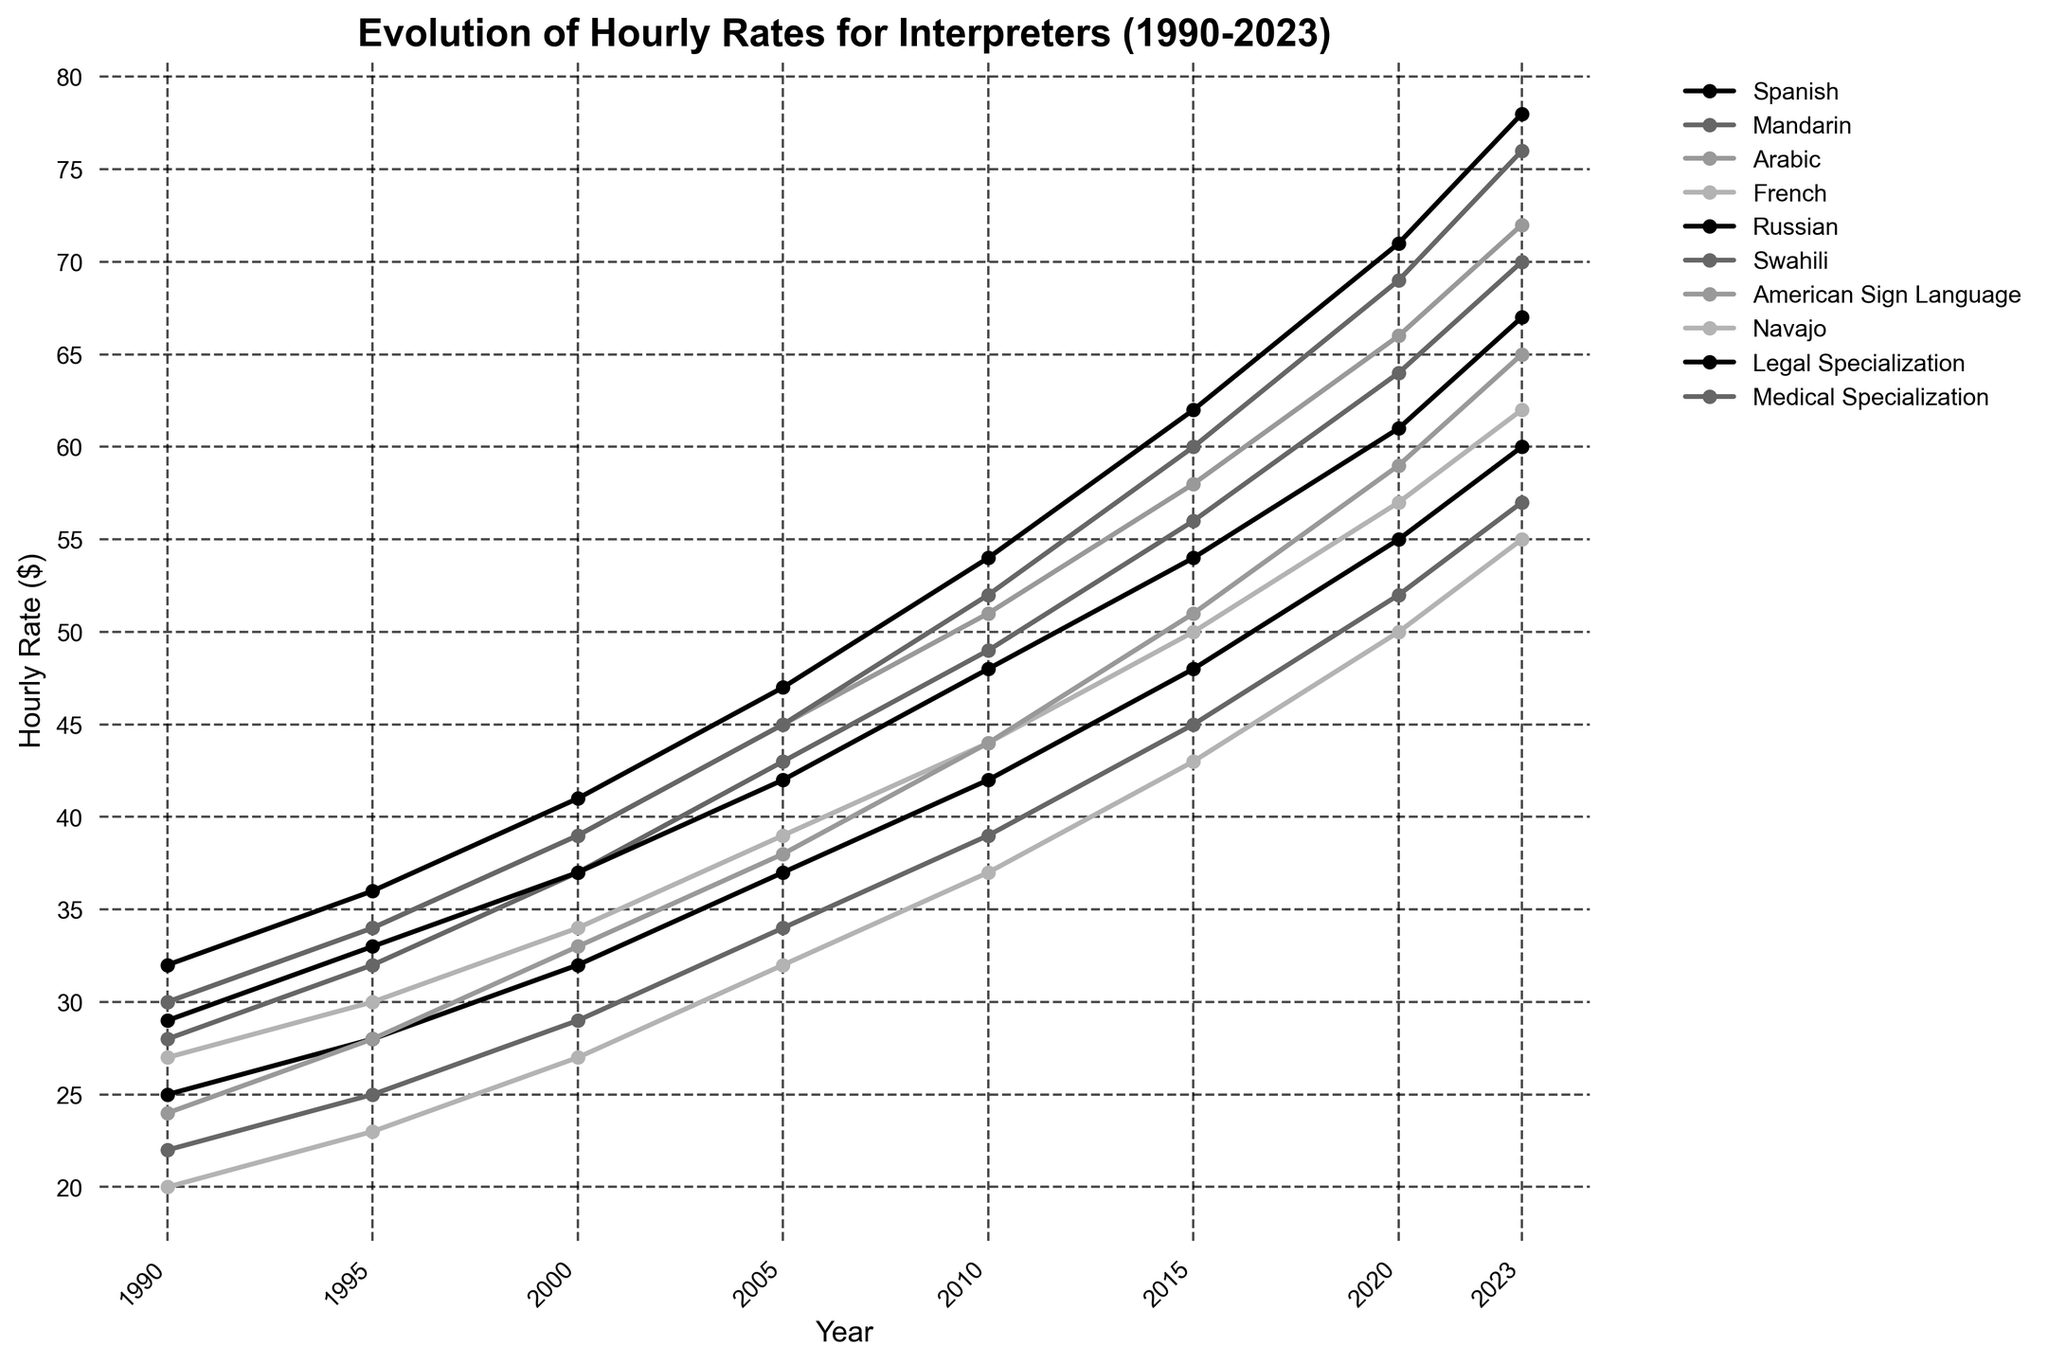Which language had the highest hourly rate in 2023? Look at the endpoints of each line in 2023 and identify the highest value. Arabic has the highest with $72 per hour.
Answer: Arabic What was the hourly rate for Navajo interpreters in 2000? Locate the value for Navajo interpreters in the column for the year 2000. The rate was $27.
Answer: $27 How much did the hourly rate for Spanish interpreters increase from 1990 to 2023? Subtract the 1990 value for Spanish interpreters from the 2023 value: $60 - $25 = $35.
Answer: $35 Which specialization saw the largest increase in hourly rates from 1990 to 2023? Calculate the differences for Legal Specialization ($78 - $32 = $46) and Medical Specialization ($76 - $30 = $46), both saw an increase of $46.
Answer: Both By how much did the hourly rate for Mandarin interpreters increase between 2015 and 2020? Subtract the 2015 value for Mandarin from the 2020 value: $64 - $56 = $8.
Answer: $8 Which language had a smaller hourly rate in 1990 compared to American Sign Language? Compare the 1990 American Sign Language value with the other languages' values. Navajo ($20) was smaller than American Sign Language ($24).
Answer: Navajo What is the average hourly rate for Legal Specialization from 1990 to 2023? Sum the hourly rates for Legal Specialization across the years and divide by the number of years: ($32 + $36 + $41 + $47 + $54 + $62 + $71 + $78) / 8 = $52.625.
Answer: $52.625 In which year did the hourly rate for Russian interpreters first exceed $50? Identify the point where the Russian line crosses the $50 mark. This happens in 2010 when the rate was $48, but it exceeded $50 in 2015 ($54).
Answer: 2015 Which language had the least consistent growth in hourly rates over the years? Look for the line with the most fluctuations or less linear growth. Swahili shows the steepest and less consistent growth pattern compared to others.
Answer: Swahili Was the hourly rate for Medical Specialization ever lower than $35 across the years? Check starting from 1990 values for Medical Specialization up to the final value. Up until 1995, the rates were below $35 but exceeded it from 2000 onwards.
Answer: Yes 